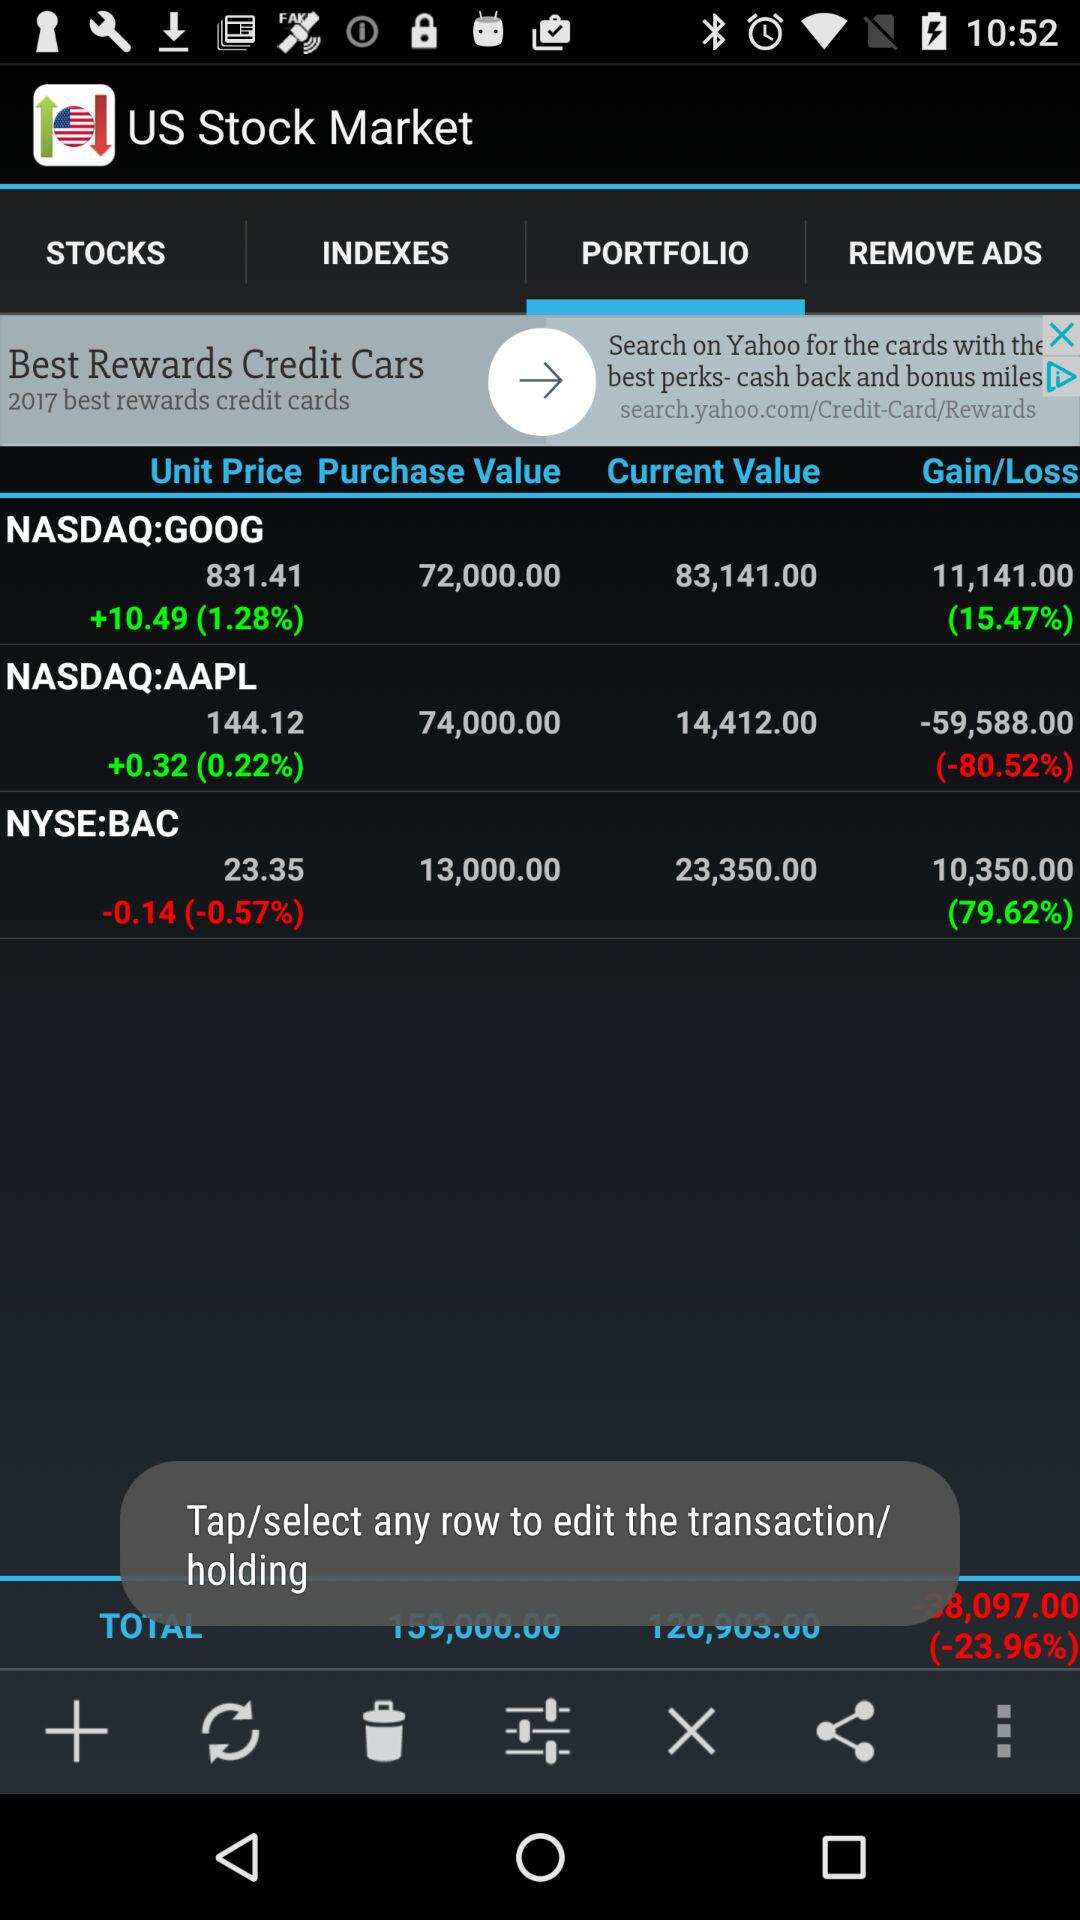What is the current market value of NASDAQ:AAPL? The current market value is 14,412. 